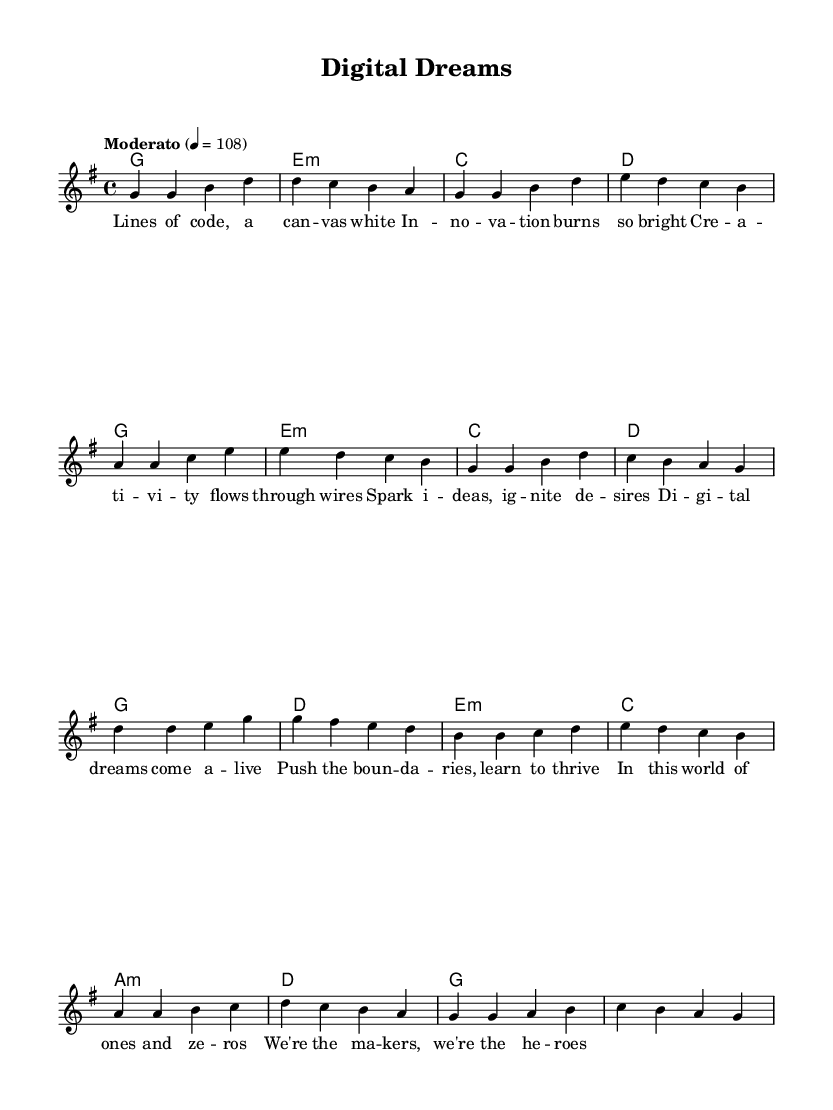What is the key signature of this music? The key signature is G major, which has one sharp (F#). You can determine this by looking at the key indication at the beginning of the sheet music.
Answer: G major What is the time signature of the piece? The time signature is 4/4, indicated at the beginning of the score. This means there are four beats in each measure and each quarter note gets one beat.
Answer: 4/4 What is the tempo marking of the piece? The tempo marking indicates "Moderato" at a speed of 108 beats per minute. This is specified in the tempo text above the staff where the rhythmic feel is set.
Answer: Moderato, 4 = 108 How many lines are in the verse lyrics? The verse contains four lines, which can be counted directly from the lyrics provided below the melody in the sheet music.
Answer: Four lines What is the last note of the chorus? The last note of the chorus is G, which can be identified by looking at the melody at the end of the chorus section, as it is written in the last measure of the chorus melody.
Answer: G What type of chords are used at the beginning of the verse? The chords used at the beginning of the verse are G major, E minor, C major, and D major, as seen in the chord symbols written above the melody in the verse.
Answer: G major, E minor, C major, D major What is the main theme expressed in the lyrics? The main theme expressed in the lyrics is creativity and innovation, which can be inferred from the words referring to digital dreams and the process of making and learning.
Answer: Creativity and innovation 